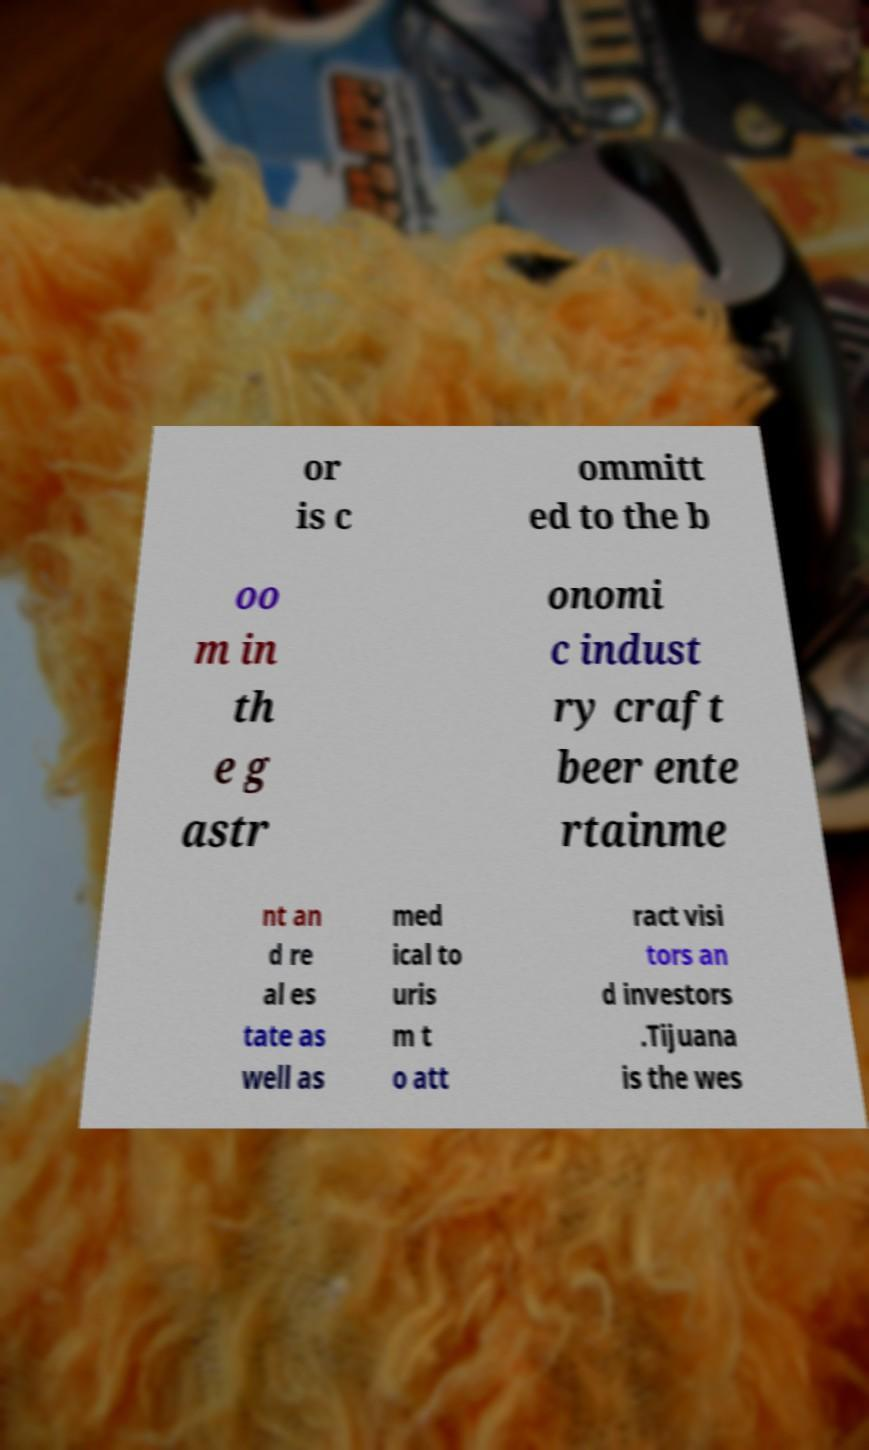What messages or text are displayed in this image? I need them in a readable, typed format. or is c ommitt ed to the b oo m in th e g astr onomi c indust ry craft beer ente rtainme nt an d re al es tate as well as med ical to uris m t o att ract visi tors an d investors .Tijuana is the wes 